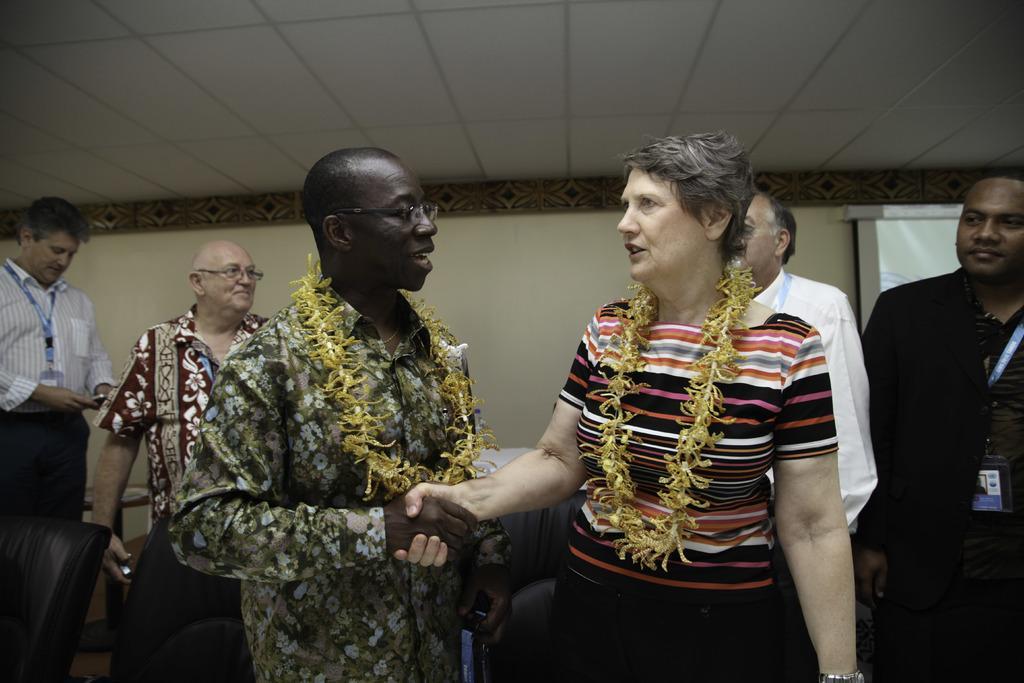Could you give a brief overview of what you see in this image? In this picture we can see two people wore garlands and standing. In the background we can see some people, wall, ceiling, screen and some objects. 